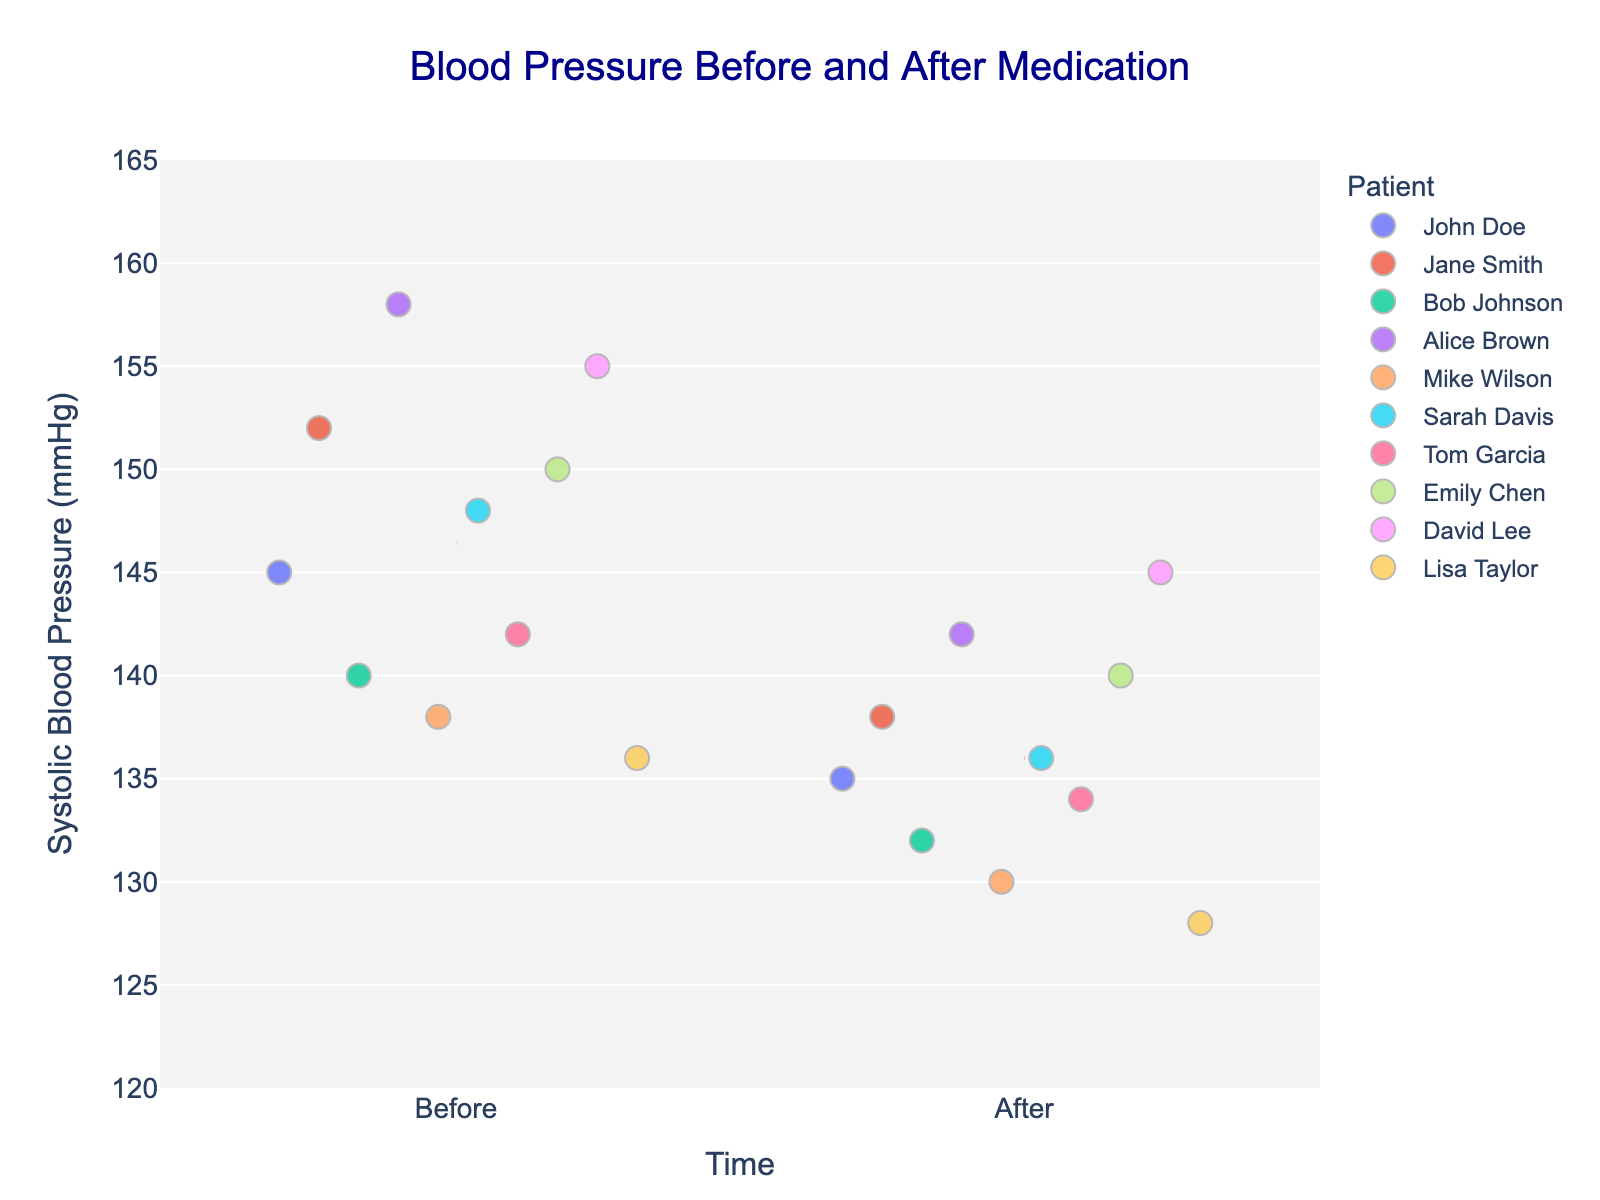What does the title of the figure say? The title is usually located at the top of the figure. It provides a summary of what the figure represents. Here, the title is "Blood Pressure Before and After Medication," which indicates the figure compares blood pressure readings before and after the medication.
Answer: Blood Pressure Before and After Medication How are the two different time points labeled on the x-axis? To find the labels on the x-axis, look at the bottom horizontal axis of the figure. You will see two categorical labels: "Before" and "After," which represent the time points before and after the medication.
Answer: Before, After What is the range of the y-axis for Systolic Blood Pressure? The y-axis represents the range of values for the systolic blood pressure. By visually checking the axis on the left side of the figure, we can see it ranges from 120 mmHg to 165 mmHg.
Answer: 120 to 165 mmHg Which patient has the highest systolic blood pressure before medication? Identify the point on the strip plot that corresponds to the highest systolic reading under the "Before" category. Jane Smith has the highest systolic value (152 mmHg).
Answer: Jane Smith What color is used to represent Sarah Davis in the figure? Look for the marker associated with Sarah Davis on both the "Before" and "After" time points. Trace her name in the legend with the color used for her data points. Sarah Davis is represented by a specific color used consistently for her readings.
Answer: (Specify the exact color seen, e.g., blue, green) Is there a general trend in systolic blood pressure after medication for the patients? Observe the values in the "After" category and compare them to the "Before" category. Draw a trend line or imagine the positioning of most markers. Generally, the systolic readings after medication seem to be lower compared to their readings before medication.
Answer: Generally decreases What is the mean systolic blood pressure after medication for all patients? We find the mean of the "After" readings by identifying the red dashed line in the "After" category, which visually indicates the average. According to the figure, the mean systolic blood pressure after medication is visible as a horizontal dashed line near the specific value.
Answer: (Specify the numerical value where the mean line is located, e.g., 135 mmHg) By how much did Jane Smith's systolic pressure decrease after medication? Find Jane Smith's systolic readings before and after medication on the plot. Subtract the "After" value from the "Before" value. Jane Smith's values change from 152 mmHg to 138 mmHg.
Answer: 14 mmHg Comparing before and after readings, which patient shows the least change in systolic blood pressure? Identify the systolic blood pressure values before and after for each patient and calculate the difference. The patient with the smallest absolute difference has the least change. The calculations show John Doe with readings of 145 mmHg and 135 mmHg, respectively, resulting in a 10 mmHg difference.
Answer: John Doe 